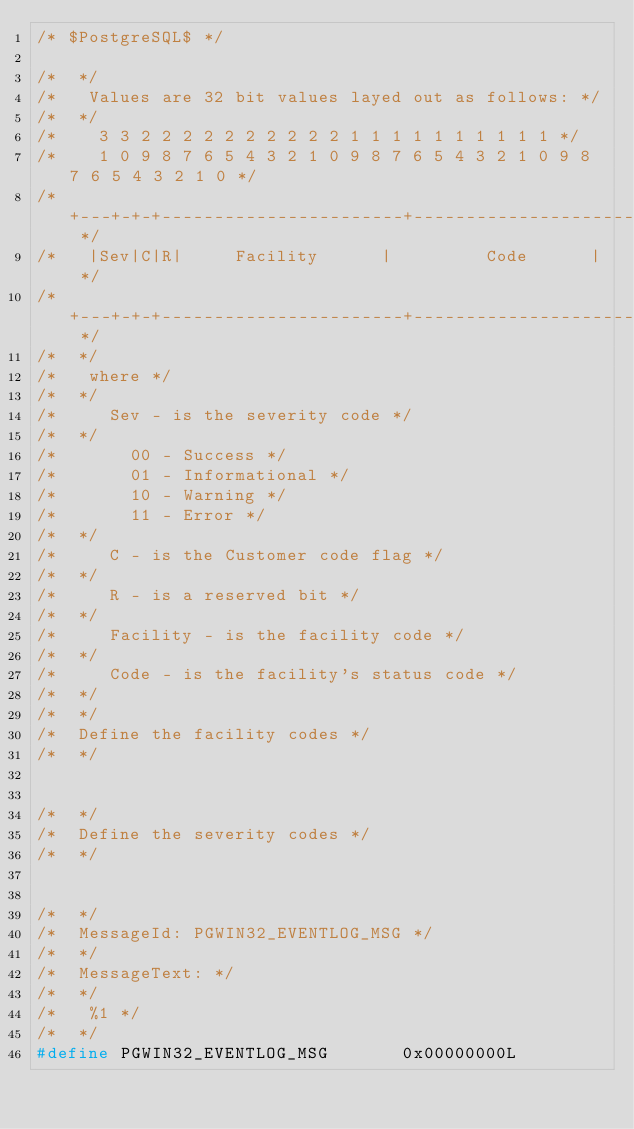Convert code to text. <code><loc_0><loc_0><loc_500><loc_500><_C_>/* $PostgreSQL$ */

/*	*/
/*	 Values are 32 bit values layed out as follows: */
/*	*/
/*	  3 3 2 2 2 2 2 2 2 2 2 2 1 1 1 1 1 1 1 1 1 1 */
/*	  1 0 9 8 7 6 5 4 3 2 1 0 9 8 7 6 5 4 3 2 1 0 9 8 7 6 5 4 3 2 1 0 */
/*	 +---+-+-+-----------------------+-------------------------------+ */
/*	 |Sev|C|R|	   Facility			 |				 Code			 | */
/*	 +---+-+-+-----------------------+-------------------------------+ */
/*	*/
/*	 where */
/*	*/
/*		 Sev - is the severity code */
/*	*/
/*			 00 - Success */
/*			 01 - Informational */
/*			 10 - Warning */
/*			 11 - Error */
/*	*/
/*		 C - is the Customer code flag */
/*	*/
/*		 R - is a reserved bit */
/*	*/
/*		 Facility - is the facility code */
/*	*/
/*		 Code - is the facility's status code */
/*	*/
/*	*/
/*	Define the facility codes */
/*	*/


/*	*/
/*	Define the severity codes */
/*	*/


/*	*/
/*	MessageId: PGWIN32_EVENTLOG_MSG */
/*	*/
/*	MessageText: */
/*	*/
/*	 %1 */
/*	*/
#define PGWIN32_EVENTLOG_MSG			 0x00000000L
</code> 